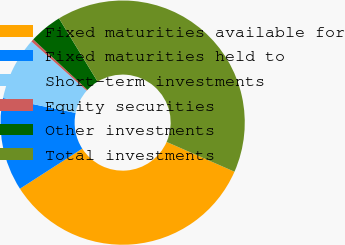Convert chart. <chart><loc_0><loc_0><loc_500><loc_500><pie_chart><fcel>Fixed maturities available for<fcel>Fixed maturities held to<fcel>Short-term investments<fcel>Equity securities<fcel>Other investments<fcel>Total investments<nl><fcel>34.32%<fcel>12.34%<fcel>8.34%<fcel>0.35%<fcel>4.35%<fcel>40.31%<nl></chart> 